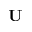Convert formula to latex. <formula><loc_0><loc_0><loc_500><loc_500>U</formula> 